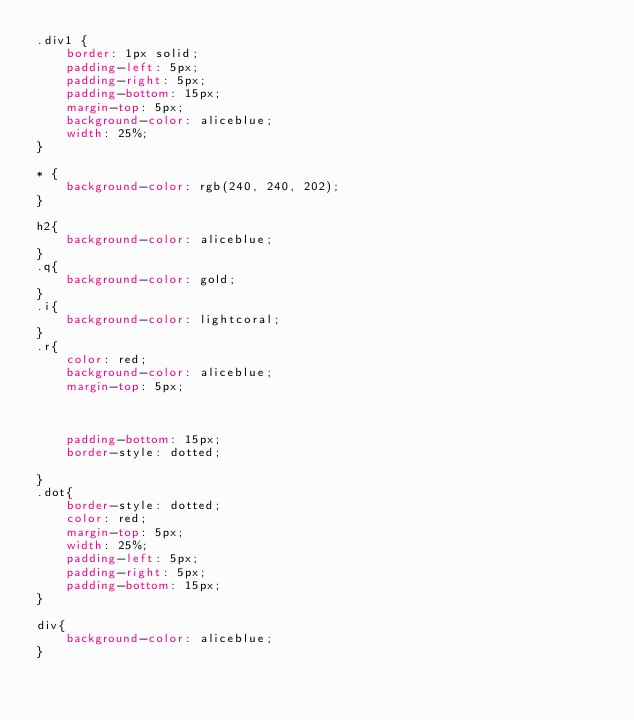Convert code to text. <code><loc_0><loc_0><loc_500><loc_500><_CSS_>.div1 {
    border: 1px solid;
    padding-left: 5px;
    padding-right: 5px;
    padding-bottom: 15px;
    margin-top: 5px;
    background-color: aliceblue;
    width: 25%;
}

* {
    background-color: rgb(240, 240, 202);
}

h2{
    background-color: aliceblue;
}
.q{
    background-color: gold;
}
.i{
    background-color: lightcoral;
}
.r{
    color: red;
    background-color: aliceblue;
    margin-top: 5px;
   
   
   
    padding-bottom: 15px;
    border-style: dotted;

}
.dot{
    border-style: dotted;
    color: red;
    margin-top: 5px;
    width: 25%;
    padding-left: 5px;
    padding-right: 5px;
    padding-bottom: 15px;
}

div{
    background-color: aliceblue;
}</code> 